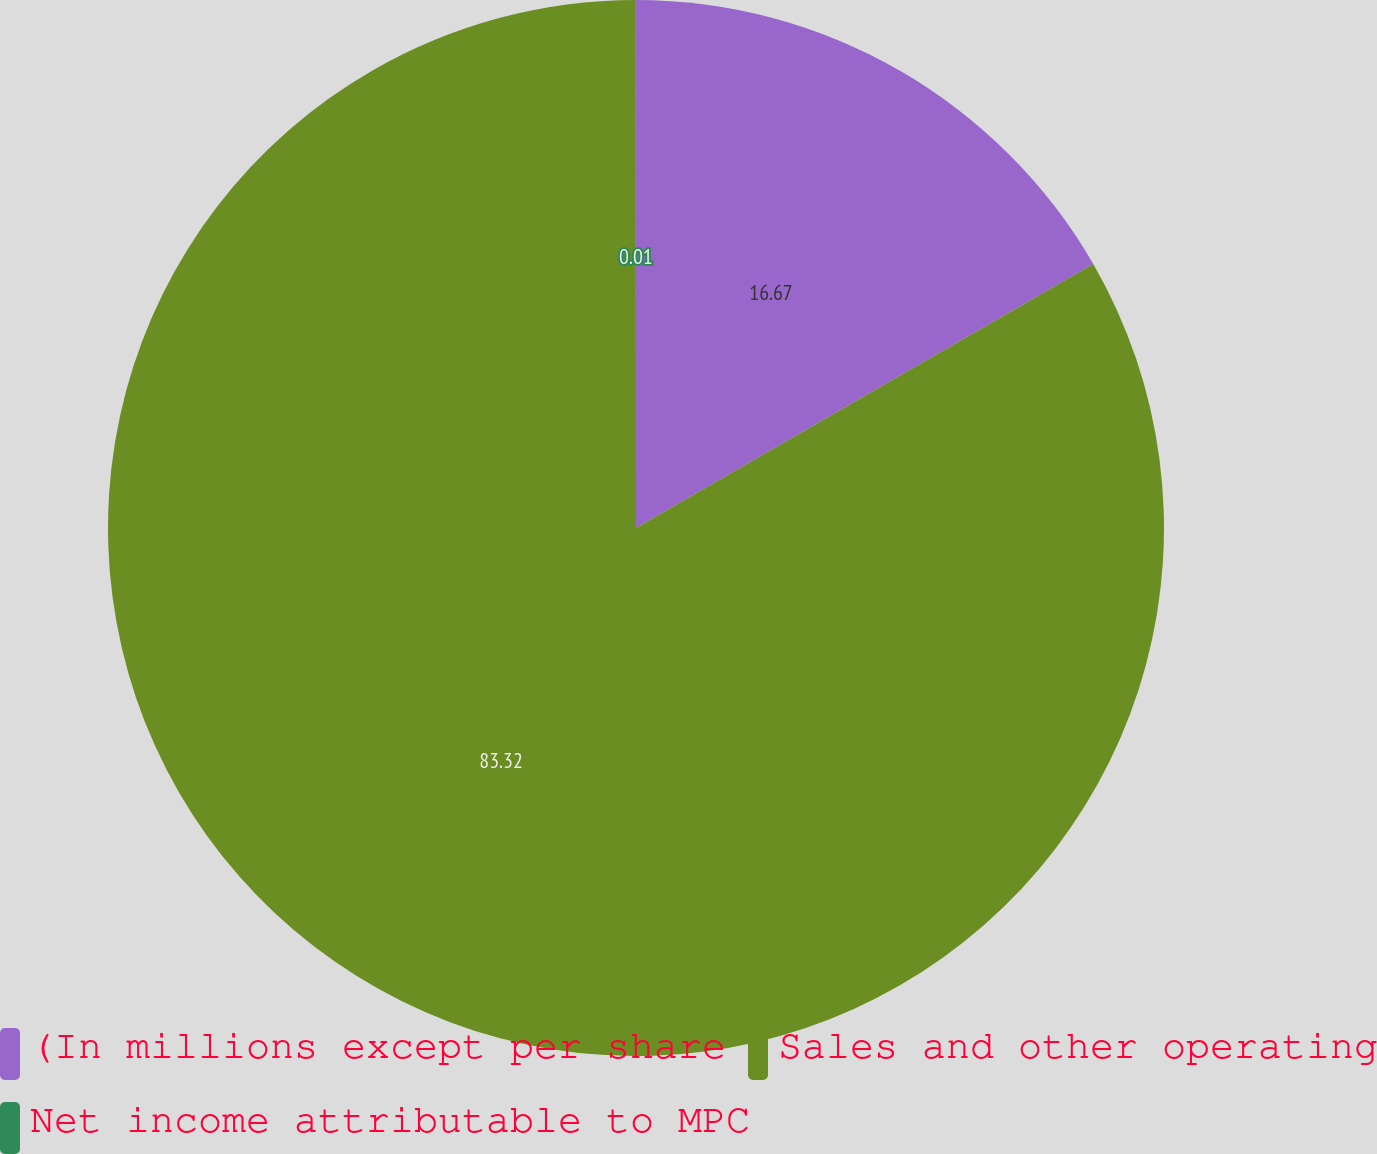<chart> <loc_0><loc_0><loc_500><loc_500><pie_chart><fcel>(In millions except per share<fcel>Sales and other operating<fcel>Net income attributable to MPC<nl><fcel>16.67%<fcel>83.33%<fcel>0.01%<nl></chart> 